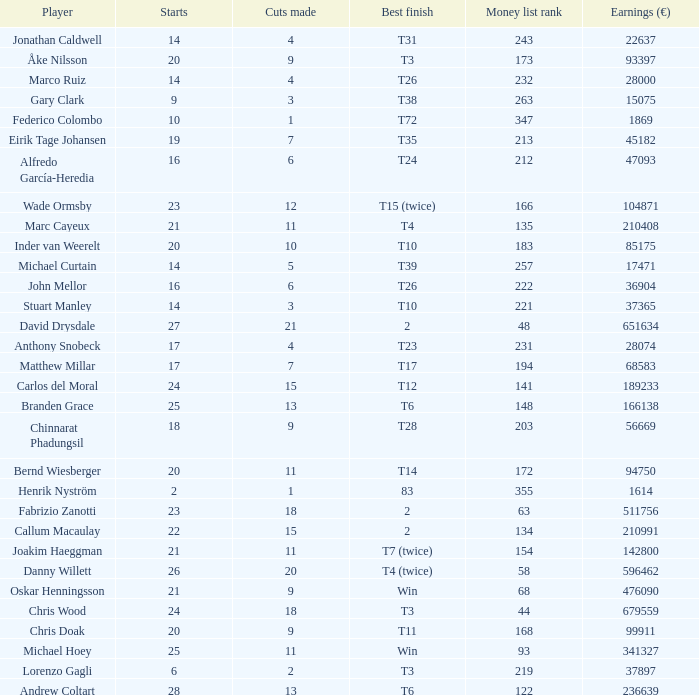How many cuts did Bernd Wiesberger make? 11.0. 